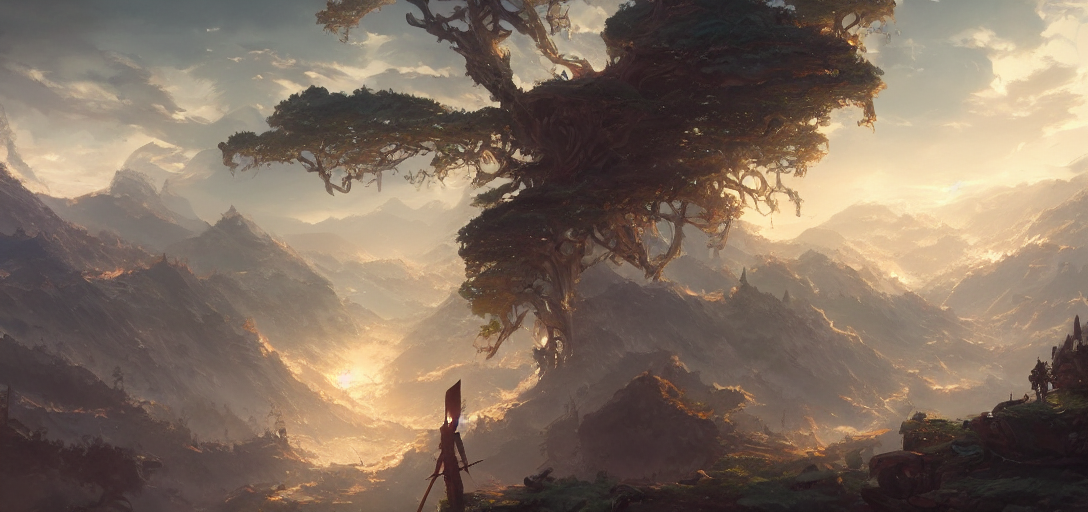Why is the content somewhat blurry?
A. Sharp
B. Unclear
C. In focus
Answer with the option's letter from the given choices directly.
 B. 